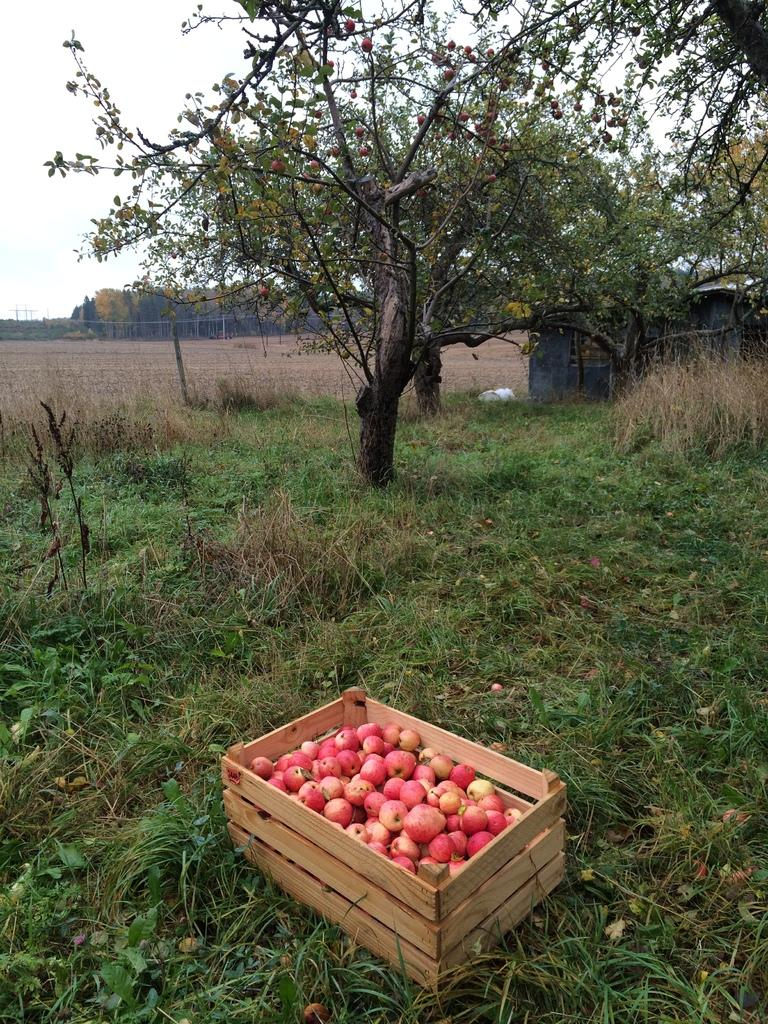What is located in the foreground of the image? There is a box with fruits in the foreground of the image. What type of vegetation is visible at the bottom of the image? There is grass at the bottom of the image. What can be seen in the background of the image? There are trees in the background of the image. What is visible in the image besides the fruits, grass, and trees? The sky is visible in the image. What type of coat is hanging on the tree in the image? There is no coat present in the image; it features a box with fruits, grass, trees, and the sky. What substance is being poured from the vase onto the grass in the image? There is no vase or substance present in the image; it only contains a box with fruits, grass, trees, and the sky. 